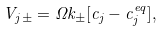Convert formula to latex. <formula><loc_0><loc_0><loc_500><loc_500>V _ { j \pm } = \Omega k _ { \pm } [ c _ { j } - c _ { j } ^ { e q } ] ,</formula> 